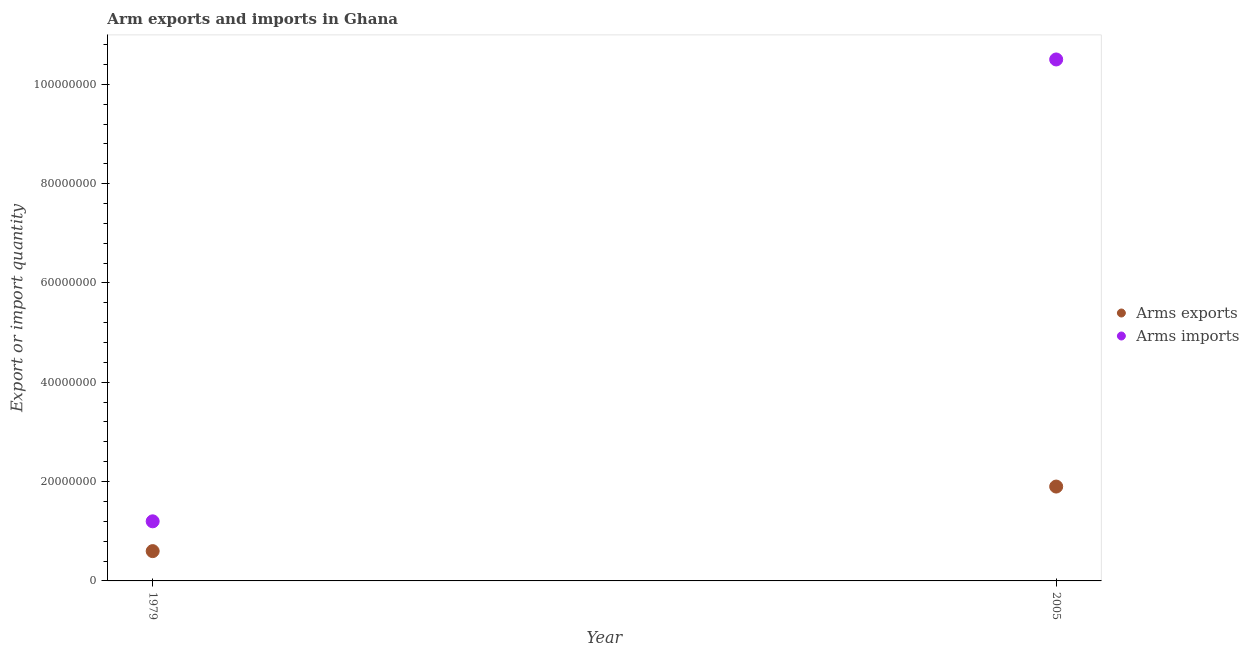What is the arms imports in 2005?
Your answer should be compact. 1.05e+08. Across all years, what is the maximum arms imports?
Give a very brief answer. 1.05e+08. Across all years, what is the minimum arms imports?
Make the answer very short. 1.20e+07. In which year was the arms exports minimum?
Provide a succinct answer. 1979. What is the total arms exports in the graph?
Ensure brevity in your answer.  2.50e+07. What is the difference between the arms exports in 1979 and that in 2005?
Offer a terse response. -1.30e+07. What is the difference between the arms exports in 1979 and the arms imports in 2005?
Your answer should be compact. -9.90e+07. What is the average arms imports per year?
Offer a very short reply. 5.85e+07. In the year 2005, what is the difference between the arms exports and arms imports?
Provide a short and direct response. -8.60e+07. In how many years, is the arms exports greater than 96000000?
Offer a terse response. 0. What is the ratio of the arms imports in 1979 to that in 2005?
Keep it short and to the point. 0.11. Does the arms imports monotonically increase over the years?
Give a very brief answer. Yes. How many dotlines are there?
Offer a very short reply. 2. Are the values on the major ticks of Y-axis written in scientific E-notation?
Keep it short and to the point. No. Does the graph contain any zero values?
Offer a terse response. No. Does the graph contain grids?
Your answer should be very brief. No. Where does the legend appear in the graph?
Provide a succinct answer. Center right. What is the title of the graph?
Your answer should be very brief. Arm exports and imports in Ghana. What is the label or title of the X-axis?
Your answer should be compact. Year. What is the label or title of the Y-axis?
Your response must be concise. Export or import quantity. What is the Export or import quantity in Arms imports in 1979?
Keep it short and to the point. 1.20e+07. What is the Export or import quantity in Arms exports in 2005?
Offer a very short reply. 1.90e+07. What is the Export or import quantity of Arms imports in 2005?
Provide a succinct answer. 1.05e+08. Across all years, what is the maximum Export or import quantity in Arms exports?
Provide a succinct answer. 1.90e+07. Across all years, what is the maximum Export or import quantity of Arms imports?
Ensure brevity in your answer.  1.05e+08. Across all years, what is the minimum Export or import quantity of Arms exports?
Provide a short and direct response. 6.00e+06. What is the total Export or import quantity in Arms exports in the graph?
Make the answer very short. 2.50e+07. What is the total Export or import quantity of Arms imports in the graph?
Your answer should be compact. 1.17e+08. What is the difference between the Export or import quantity in Arms exports in 1979 and that in 2005?
Give a very brief answer. -1.30e+07. What is the difference between the Export or import quantity in Arms imports in 1979 and that in 2005?
Give a very brief answer. -9.30e+07. What is the difference between the Export or import quantity of Arms exports in 1979 and the Export or import quantity of Arms imports in 2005?
Offer a terse response. -9.90e+07. What is the average Export or import quantity of Arms exports per year?
Offer a very short reply. 1.25e+07. What is the average Export or import quantity in Arms imports per year?
Provide a short and direct response. 5.85e+07. In the year 1979, what is the difference between the Export or import quantity of Arms exports and Export or import quantity of Arms imports?
Your response must be concise. -6.00e+06. In the year 2005, what is the difference between the Export or import quantity in Arms exports and Export or import quantity in Arms imports?
Ensure brevity in your answer.  -8.60e+07. What is the ratio of the Export or import quantity in Arms exports in 1979 to that in 2005?
Make the answer very short. 0.32. What is the ratio of the Export or import quantity of Arms imports in 1979 to that in 2005?
Offer a very short reply. 0.11. What is the difference between the highest and the second highest Export or import quantity of Arms exports?
Ensure brevity in your answer.  1.30e+07. What is the difference between the highest and the second highest Export or import quantity in Arms imports?
Your response must be concise. 9.30e+07. What is the difference between the highest and the lowest Export or import quantity of Arms exports?
Offer a terse response. 1.30e+07. What is the difference between the highest and the lowest Export or import quantity in Arms imports?
Ensure brevity in your answer.  9.30e+07. 